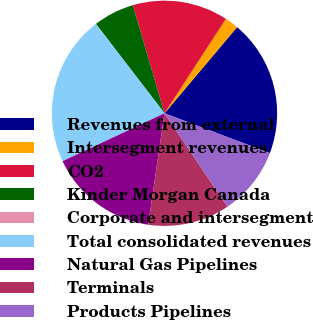Convert chart. <chart><loc_0><loc_0><loc_500><loc_500><pie_chart><fcel>Revenues from external<fcel>Intersegment revenues<fcel>CO2<fcel>Kinder Morgan Canada<fcel>Corporate and intersegment<fcel>Total consolidated revenues<fcel>Natural Gas Pipelines<fcel>Terminals<fcel>Products Pipelines<nl><fcel>19.61%<fcel>1.96%<fcel>13.72%<fcel>5.88%<fcel>0.0%<fcel>21.57%<fcel>15.69%<fcel>11.76%<fcel>9.8%<nl></chart> 